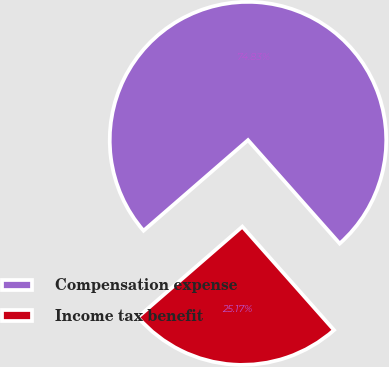Convert chart to OTSL. <chart><loc_0><loc_0><loc_500><loc_500><pie_chart><fcel>Compensation expense<fcel>Income tax benefit<nl><fcel>74.83%<fcel>25.17%<nl></chart> 